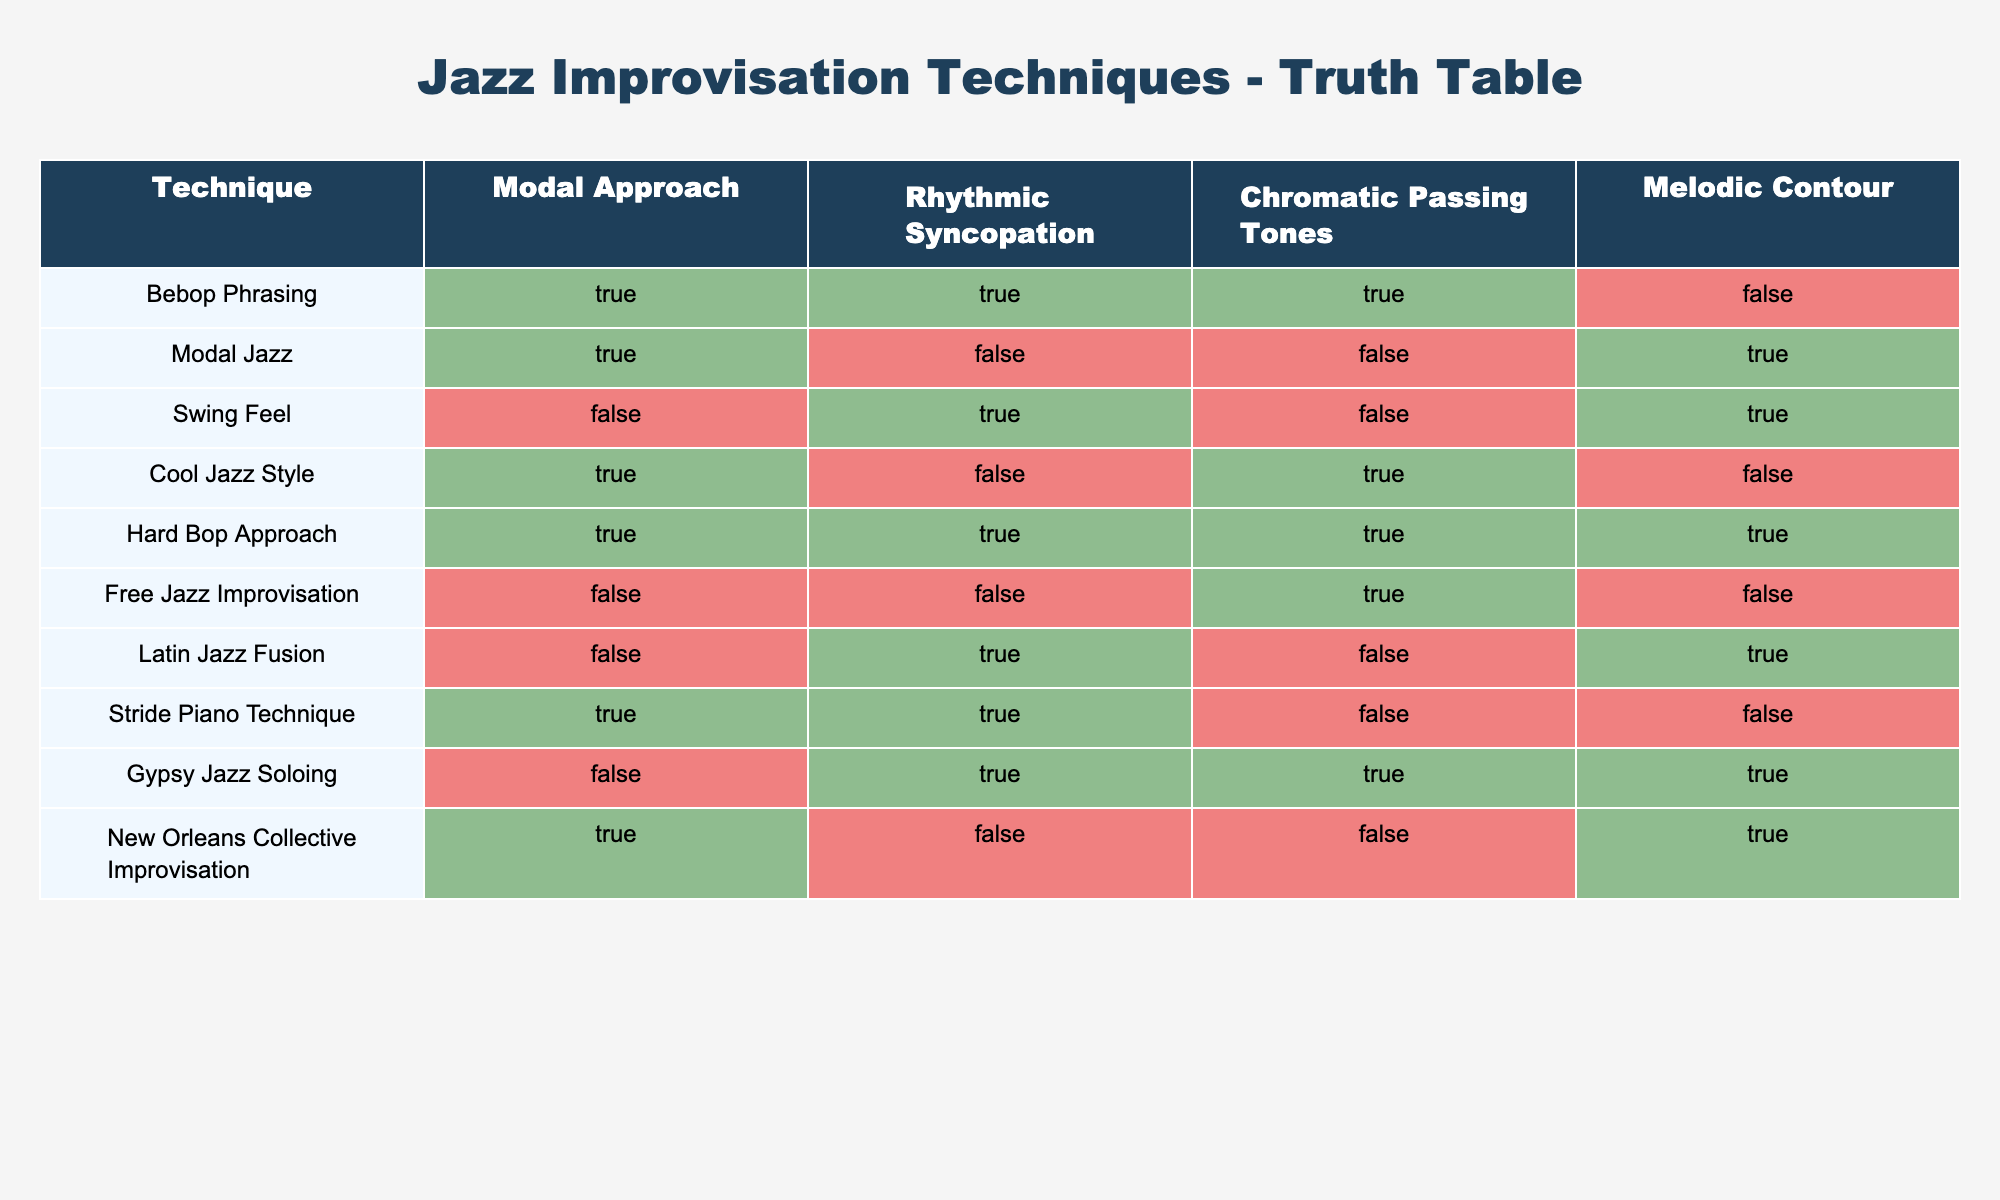What jazz improvisation technique has rhythmic syncopation and chromatic passing tones? To find the answer, we look for rows that have "TRUE" under both "Rhythmic Syncopation" and "Chromatic Passing Tones." The technique that fulfills this criterion is "Hard Bop Approach," as it has "TRUE" for both attributes.
Answer: Hard Bop Approach Which technique does not use a modal approach? We check the "Modal Approach" column for all techniques marked as "FALSE." The techniques that do not utilize a modal approach are "Swing Feel," "Free Jazz Improvisation," "Latin Jazz Fusion," and "Gypsy Jazz Soloing."
Answer: Swing Feel, Free Jazz Improvisation, Latin Jazz Fusion, Gypsy Jazz Soloing How many techniques use melodic contour? We count the rows where "Melodic Contour" is marked as "TRUE." Inspecting the table, the techniques with "TRUE" for "Melodic Contour" are "Modal Jazz," "Swing Feel," "Hard Bop Approach," "Latin Jazz Fusion," and "New Orleans Collective Improvisation," totaling 5 techniques.
Answer: 5 Is there any technique that combines all four attributes? We search for a row where all four criteria (Modal Approach, Rhythmic Syncopation, Chromatic Passing Tones, Melodic Contour) are "TRUE." The only technique matching this condition is "Hard Bop Approach." Therefore, the answer is yes.
Answer: Yes What is the total number of techniques that utilize the modal approach and rhythmic syncopation? We look for techniques with both "Modal Approach" and "Rhythmic Syncopation" marked as "TRUE." Those techniques are "Bebop Phrasing," "Hard Bop Approach," and "Stride Piano Technique," adding up to a total of 3 techniques.
Answer: 3 Which technique features chromatic passing tones but lacks rhythmic syncopation? We find the technique marked "TRUE" under "Chromatic Passing Tones" and "FALSE" under "Rhythmic Syncopation." The technique that satisfies this condition is "Cool Jazz Style."
Answer: Cool Jazz Style What percentage of techniques employ a modal approach? First, we identify how many techniques have "TRUE" under "Modal Approach," which are 6 out of a total of 10 techniques. To find the percentage, we calculate (6/10) * 100 = 60%.
Answer: 60% Which technique uses both rhythmic syncopation and melodic contour but not chromatic passing tones? We check the criteria for techniques marked "TRUE" under both "Rhythmic Syncopation" and "Melodic Contour," and "FALSE" under "Chromatic Passing Tones." The technique that fits this description is "Swing Feel."
Answer: Swing Feel 